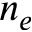Convert formula to latex. <formula><loc_0><loc_0><loc_500><loc_500>n _ { e }</formula> 